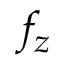<formula> <loc_0><loc_0><loc_500><loc_500>f _ { z }</formula> 